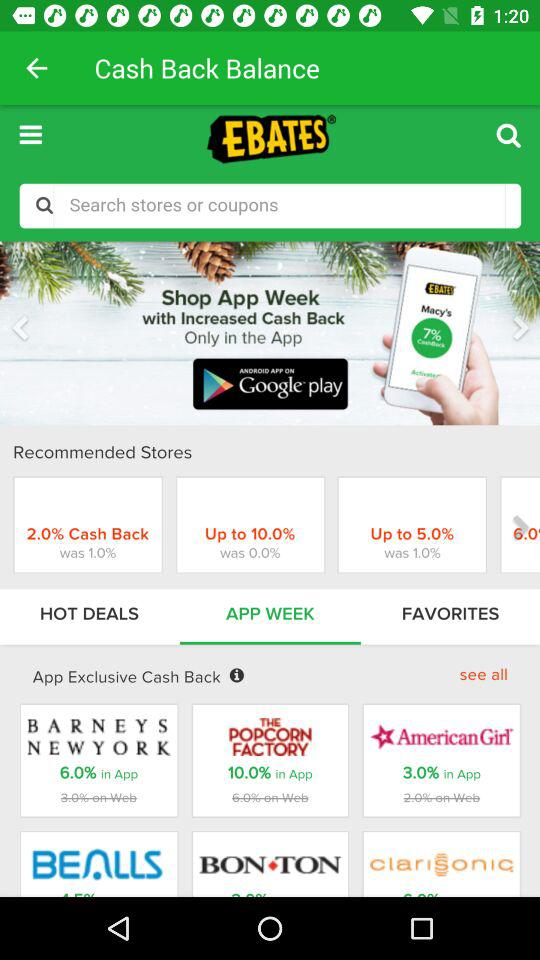How much exclusive cashback is in the "AmericanGirl" app? The exclusive cashback in the "AmericanGirl" app is 3%. 